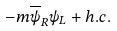<formula> <loc_0><loc_0><loc_500><loc_500>- m \overline { \psi } _ { R } \psi _ { L } + h . c .</formula> 